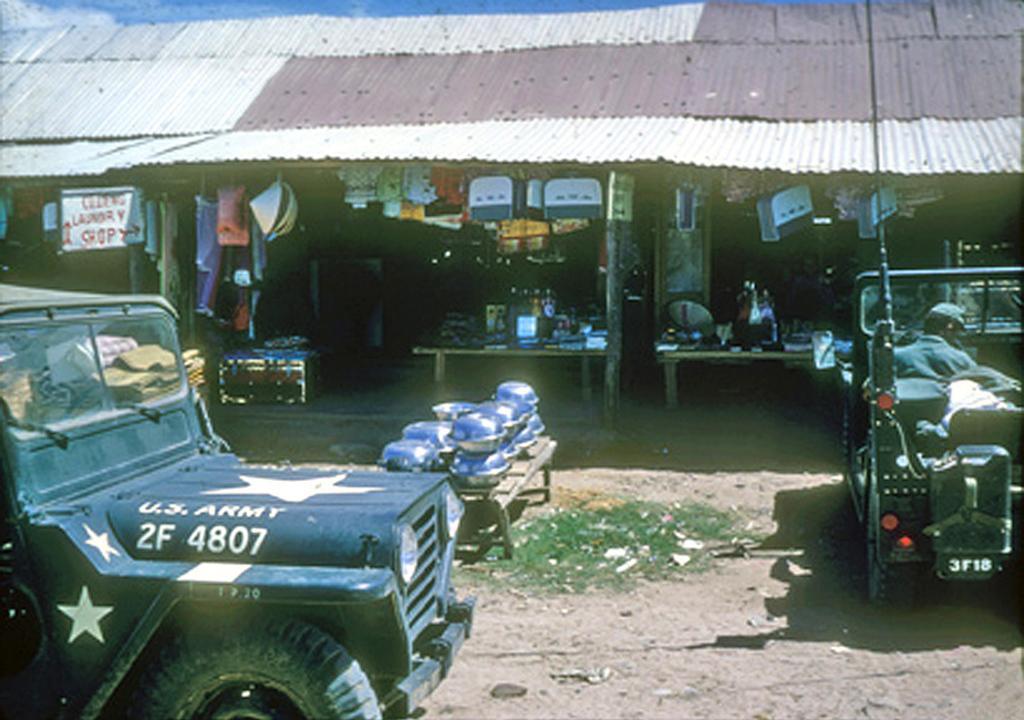Could you give a brief overview of what you see in this image? In the picture,there are some stores under a shed and in front of the stores there are two vehicles,in the second vehicle there is a man sitting in front of the steering. 